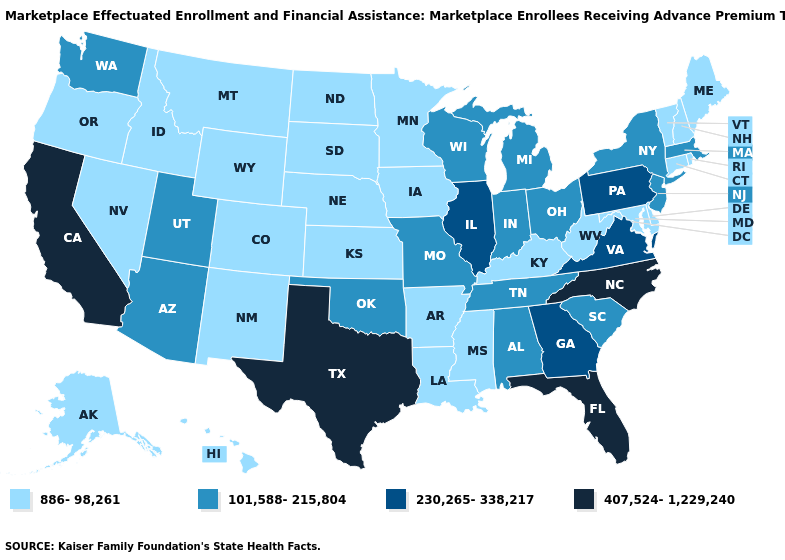What is the lowest value in states that border Texas?
Short answer required. 886-98,261. Does the first symbol in the legend represent the smallest category?
Write a very short answer. Yes. Name the states that have a value in the range 886-98,261?
Be succinct. Alaska, Arkansas, Colorado, Connecticut, Delaware, Hawaii, Idaho, Iowa, Kansas, Kentucky, Louisiana, Maine, Maryland, Minnesota, Mississippi, Montana, Nebraska, Nevada, New Hampshire, New Mexico, North Dakota, Oregon, Rhode Island, South Dakota, Vermont, West Virginia, Wyoming. Does Louisiana have the same value as Maryland?
Answer briefly. Yes. What is the value of Maine?
Short answer required. 886-98,261. What is the value of California?
Keep it brief. 407,524-1,229,240. Does Montana have a higher value than Tennessee?
Answer briefly. No. Name the states that have a value in the range 886-98,261?
Short answer required. Alaska, Arkansas, Colorado, Connecticut, Delaware, Hawaii, Idaho, Iowa, Kansas, Kentucky, Louisiana, Maine, Maryland, Minnesota, Mississippi, Montana, Nebraska, Nevada, New Hampshire, New Mexico, North Dakota, Oregon, Rhode Island, South Dakota, Vermont, West Virginia, Wyoming. Which states have the lowest value in the South?
Write a very short answer. Arkansas, Delaware, Kentucky, Louisiana, Maryland, Mississippi, West Virginia. Which states hav the highest value in the South?
Be succinct. Florida, North Carolina, Texas. How many symbols are there in the legend?
Be succinct. 4. Name the states that have a value in the range 101,588-215,804?
Write a very short answer. Alabama, Arizona, Indiana, Massachusetts, Michigan, Missouri, New Jersey, New York, Ohio, Oklahoma, South Carolina, Tennessee, Utah, Washington, Wisconsin. Does the map have missing data?
Answer briefly. No. Which states hav the highest value in the Northeast?
Concise answer only. Pennsylvania. Name the states that have a value in the range 407,524-1,229,240?
Keep it brief. California, Florida, North Carolina, Texas. 